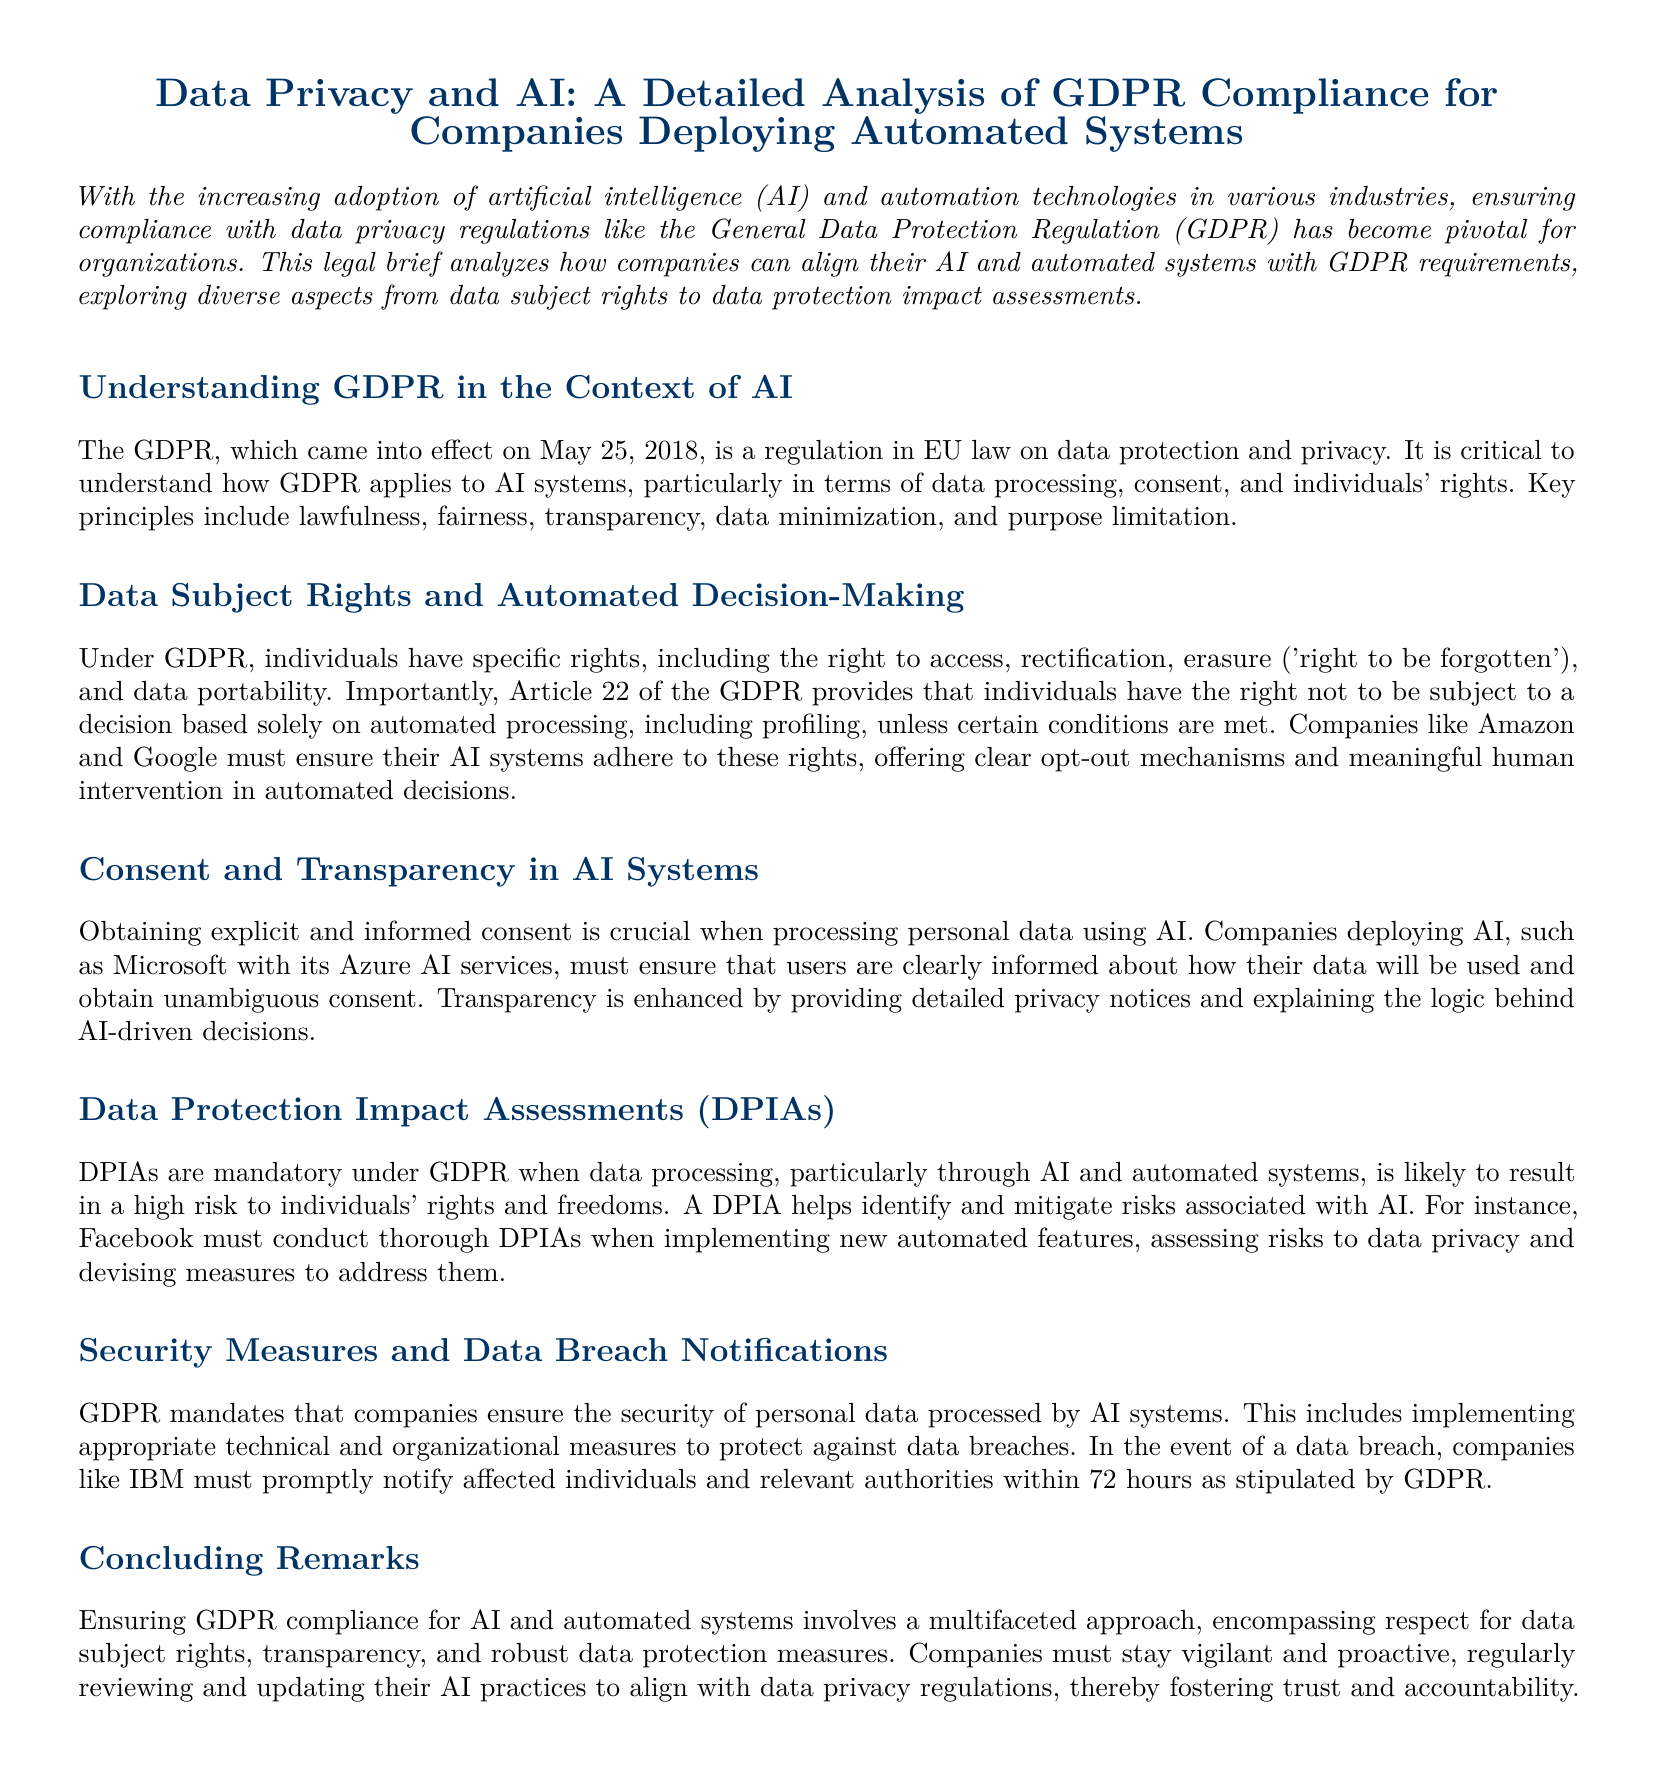What is the title of the document? The title is stated clearly at the beginning of the document, which is "Data Privacy and AI: A Detailed Analysis of GDPR Compliance for Companies Deploying Automated Systems."
Answer: Data Privacy and AI: A Detailed Analysis of GDPR Compliance for Companies Deploying Automated Systems When did GDPR come into effect? The document specifies the effective date of GDPR, which is a significant detail in its introduction.
Answer: May 25, 2018 What right does Article 22 of the GDPR provide? This article specifically addresses rights related to automated decision-making, as outlined in the relevant section of the document.
Answer: Right not to be subject to a decision based solely on automated processing Which company is mentioned as needing to conduct DPIAs? The document includes examples of companies that must perform DPIAs, highlighting the responsibilities of well-known organizations in relation to GDPR compliance.
Answer: Facebook What is the time limit for notifying authorities of a data breach? The document discusses the obligations of companies regarding data breach notifications, including the precise time frame mentioned.
Answer: 72 hours Why is consent crucial in processing personal data using AI? The document emphasizes the importance of consent and transparency when personal data is processed, reflecting the regulatory requirements.
Answer: Explicit and informed consent What does DPIA stand for? This acronym is introduced and explained in the context of data protection in the document.
Answer: Data Protection Impact Assessments What principle is NOT listed under the key principles of GDPR? The principles are enumerated in the context of GDPR application to AI systems; the question challenges the reader to recall essential principles.
Answer: N/A (the answer expects a principle not mentioned in the list) What is one measure companies must implement to ensure data security? The document discusses the obligations under GDPR for companies regarding data security measures, hinting at necessary practices for compliance.
Answer: Appropriate technical and organizational measures 